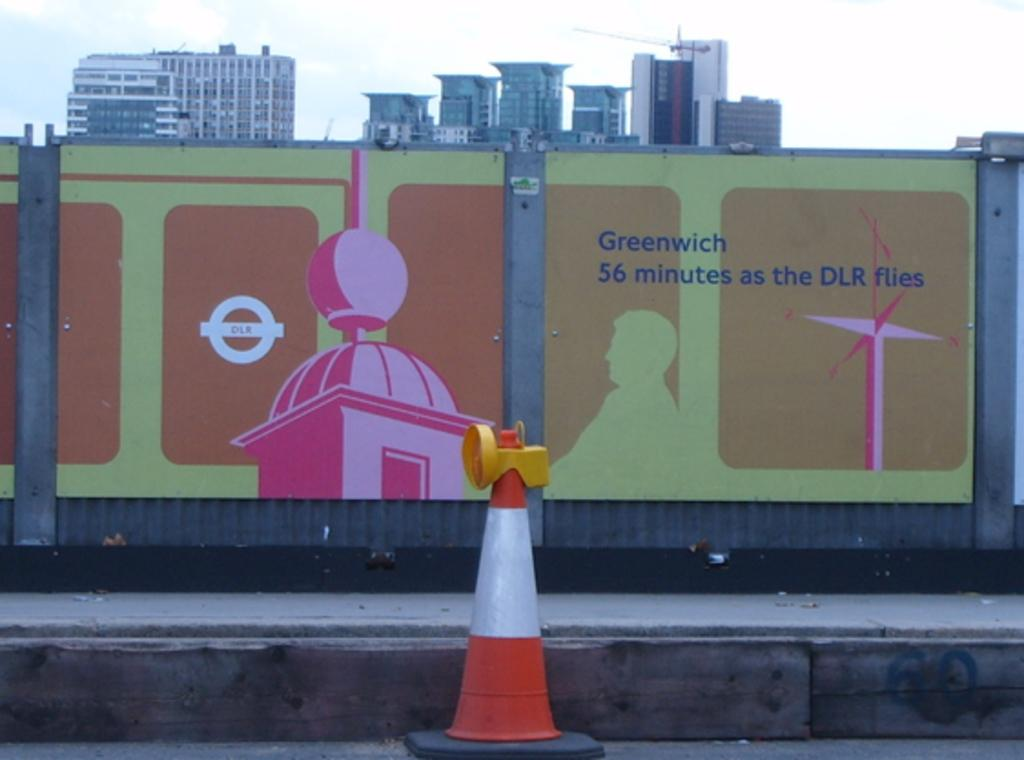<image>
Relay a brief, clear account of the picture shown. the mural on the wall says that Greenwish is 56 minutes as the DLR flies 